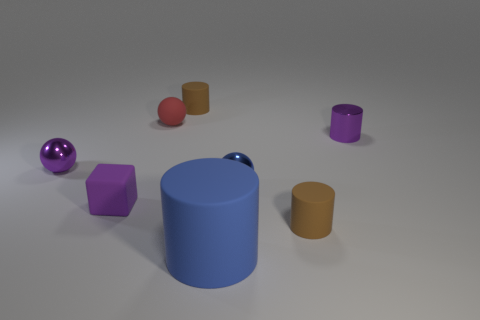The tiny red rubber object that is behind the blue ball has what shape?
Provide a short and direct response. Sphere. What material is the large cylinder?
Keep it short and to the point. Rubber. There is a metallic cylinder that is the same size as the purple rubber object; what is its color?
Keep it short and to the point. Purple. What is the shape of the small shiny object that is the same color as the large cylinder?
Provide a short and direct response. Sphere. Is the tiny red object the same shape as the tiny blue shiny object?
Offer a terse response. Yes. There is a small cylinder that is behind the blue metal ball and in front of the red rubber object; what material is it made of?
Provide a short and direct response. Metal. What is the size of the blue matte object?
Your answer should be very brief. Large. There is another shiny object that is the same shape as the small blue thing; what is its color?
Keep it short and to the point. Purple. Is there anything else that is the same color as the rubber sphere?
Make the answer very short. No. There is a rubber block that is in front of the small red rubber thing; does it have the same size as the brown matte object that is to the left of the tiny blue thing?
Keep it short and to the point. Yes. 